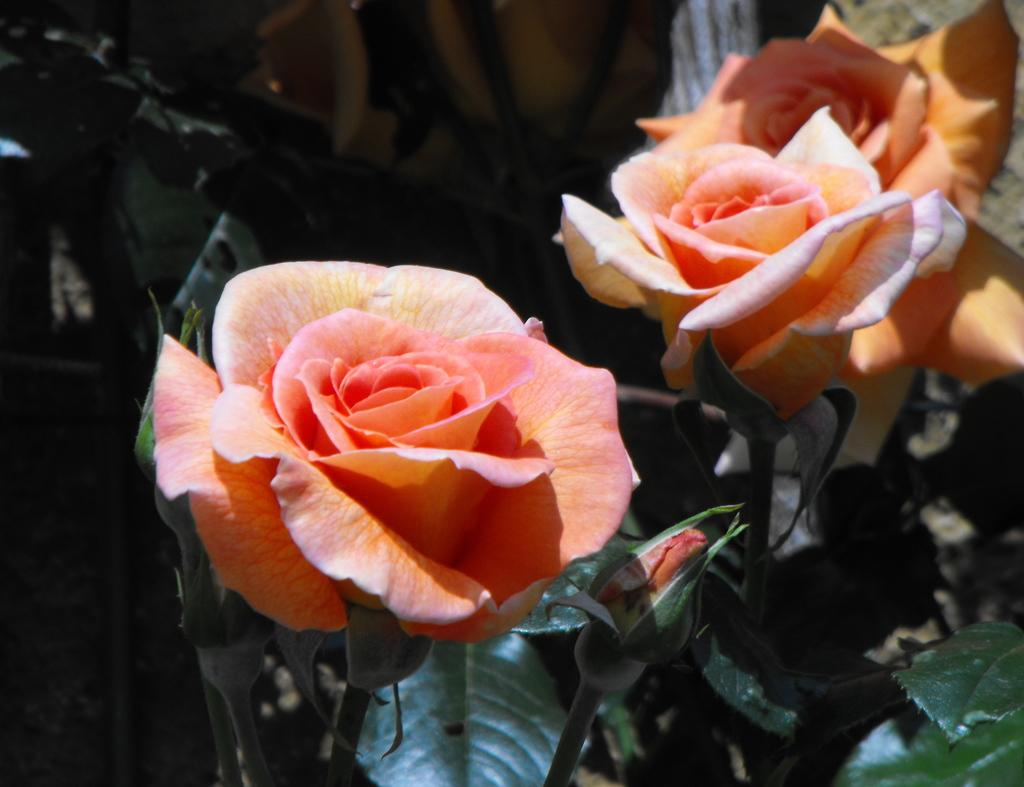What type of living organisms can be seen in the image? There are flowers and plants in the image. Can you describe the plants in the image? The plants in the image are not specified, but they are present alongside the flowers. How many ducks are visible in the image? There are no ducks present in the image. What type of cloud can be seen in the image? There is no cloud visible in the image; it only features flowers and plants. 